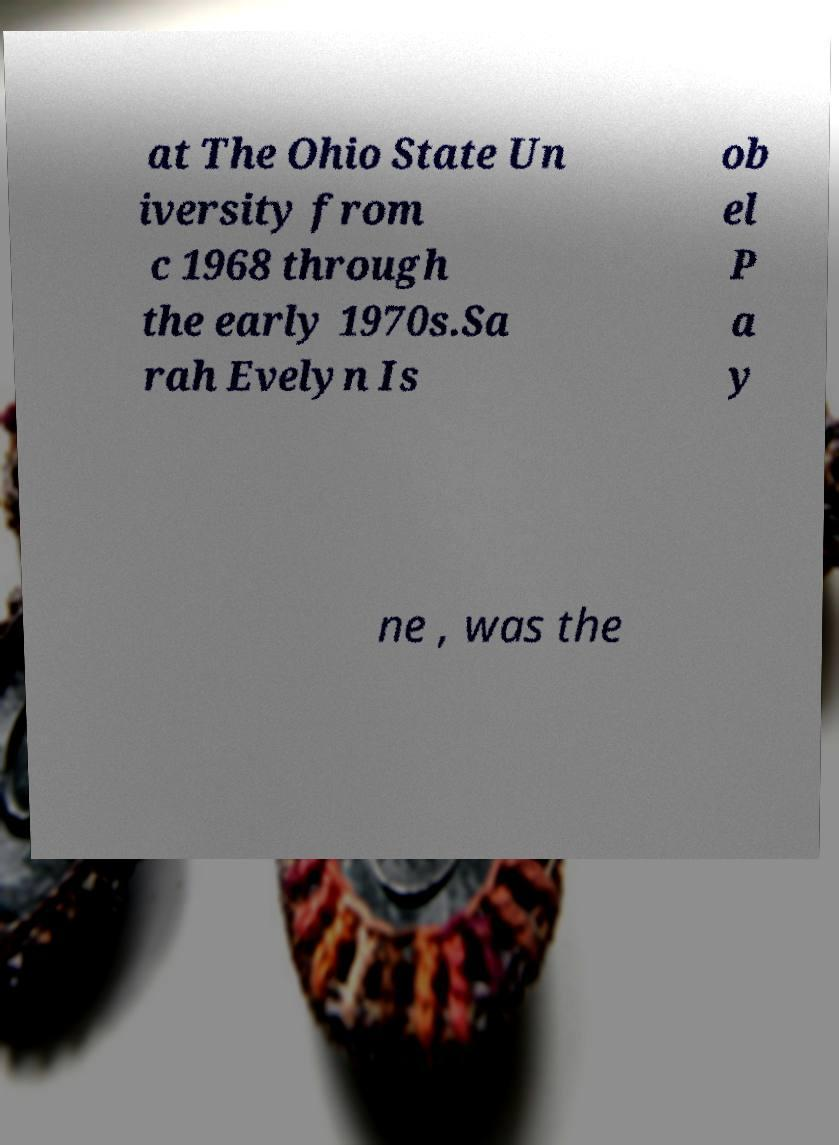There's text embedded in this image that I need extracted. Can you transcribe it verbatim? at The Ohio State Un iversity from c 1968 through the early 1970s.Sa rah Evelyn Is ob el P a y ne , was the 